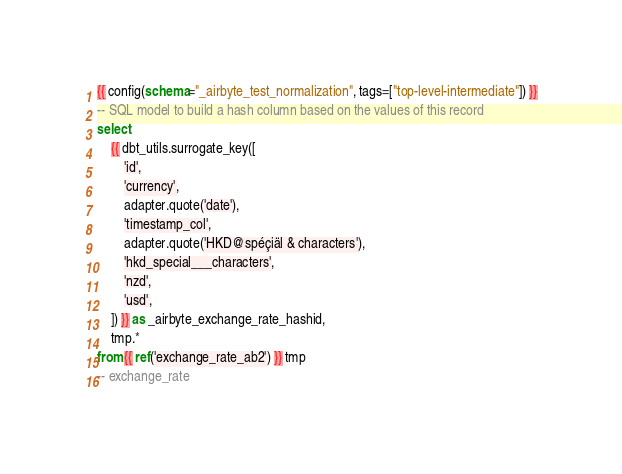Convert code to text. <code><loc_0><loc_0><loc_500><loc_500><_SQL_>{{ config(schema="_airbyte_test_normalization", tags=["top-level-intermediate"]) }}
-- SQL model to build a hash column based on the values of this record
select
    {{ dbt_utils.surrogate_key([
        'id',
        'currency',
        adapter.quote('date'),
        'timestamp_col',
        adapter.quote('HKD@spéçiäl & characters'),
        'hkd_special___characters',
        'nzd',
        'usd',
    ]) }} as _airbyte_exchange_rate_hashid,
    tmp.*
from {{ ref('exchange_rate_ab2') }} tmp
-- exchange_rate

</code> 